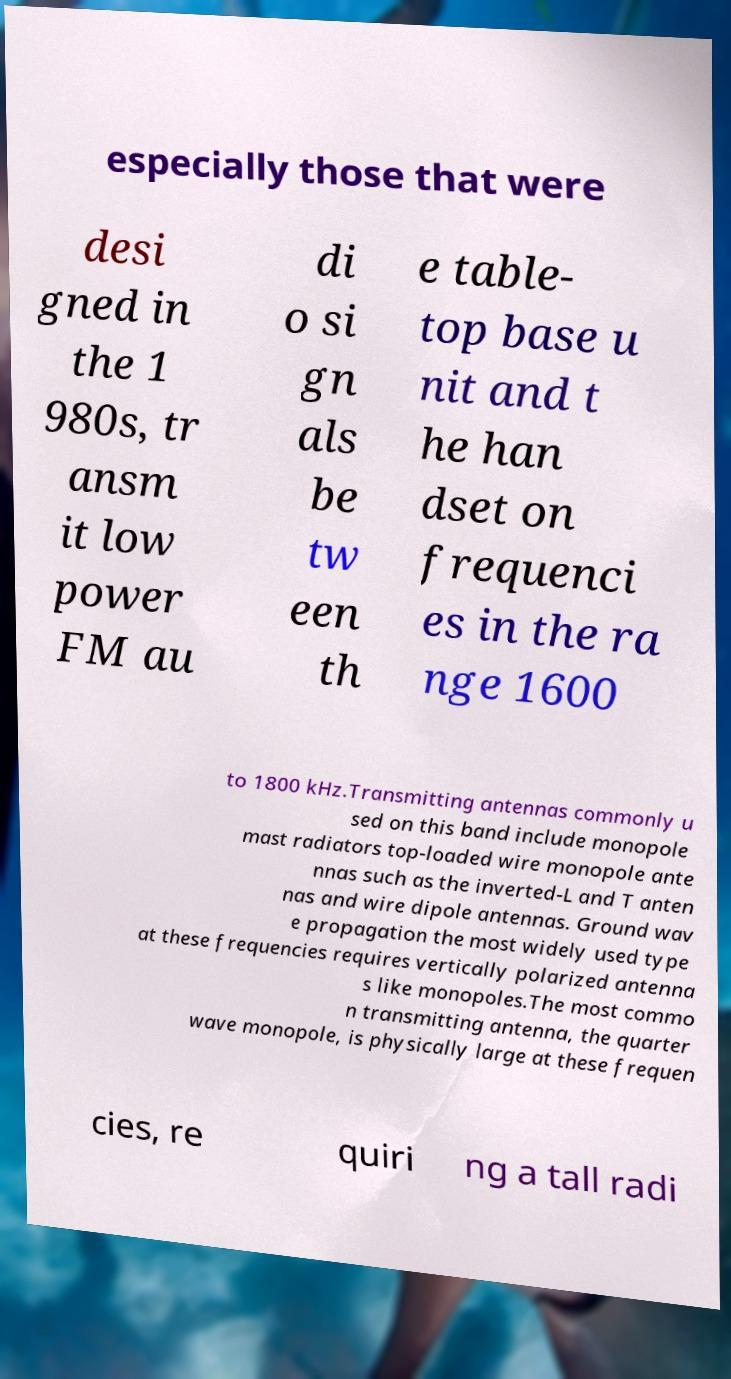For documentation purposes, I need the text within this image transcribed. Could you provide that? especially those that were desi gned in the 1 980s, tr ansm it low power FM au di o si gn als be tw een th e table- top base u nit and t he han dset on frequenci es in the ra nge 1600 to 1800 kHz.Transmitting antennas commonly u sed on this band include monopole mast radiators top-loaded wire monopole ante nnas such as the inverted-L and T anten nas and wire dipole antennas. Ground wav e propagation the most widely used type at these frequencies requires vertically polarized antenna s like monopoles.The most commo n transmitting antenna, the quarter wave monopole, is physically large at these frequen cies, re quiri ng a tall radi 